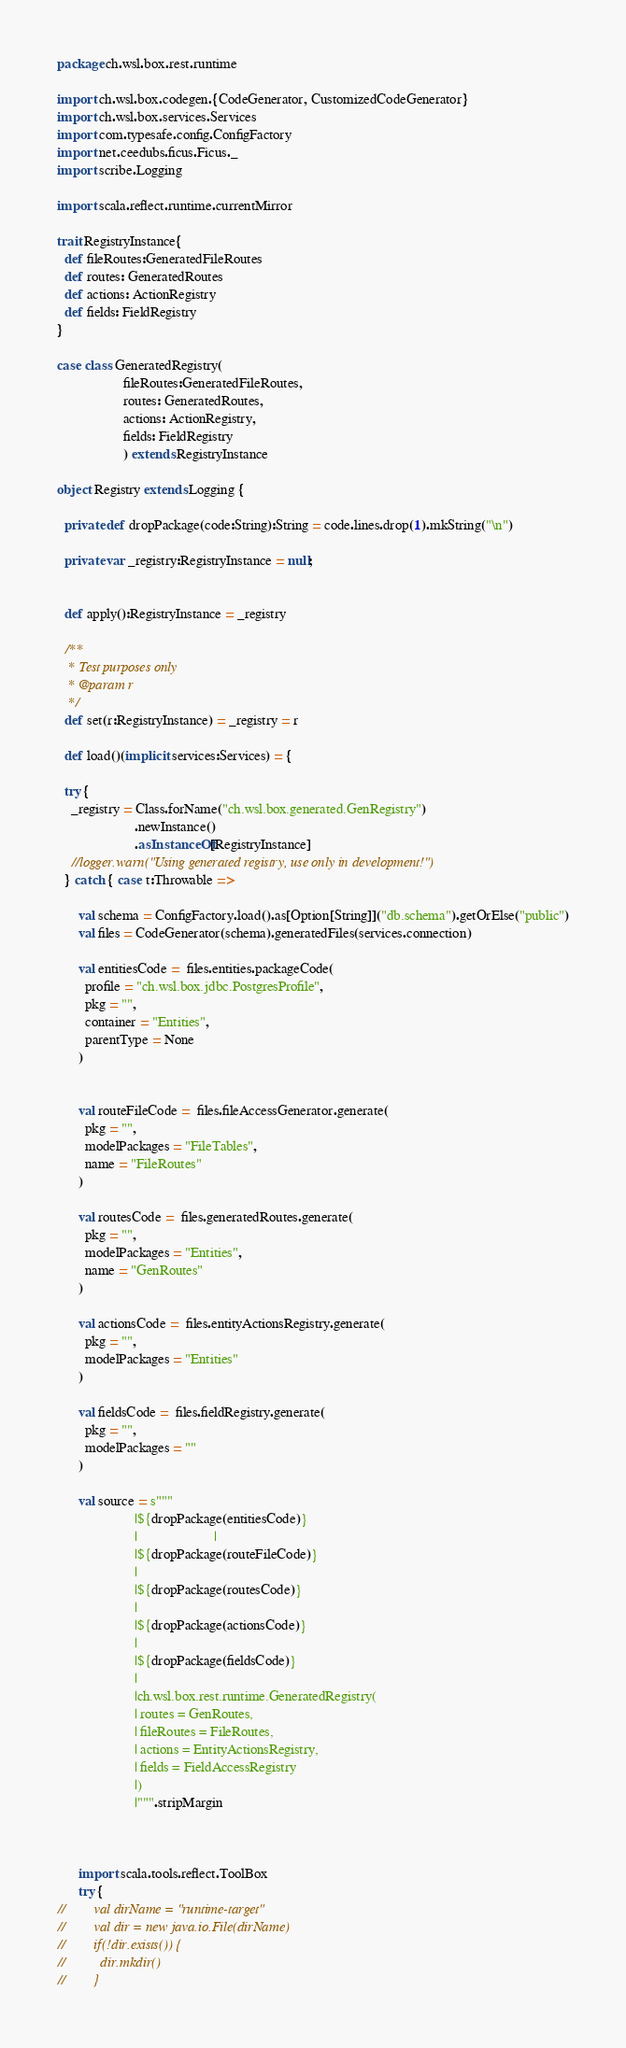<code> <loc_0><loc_0><loc_500><loc_500><_Scala_>package ch.wsl.box.rest.runtime

import ch.wsl.box.codegen.{CodeGenerator, CustomizedCodeGenerator}
import ch.wsl.box.services.Services
import com.typesafe.config.ConfigFactory
import net.ceedubs.ficus.Ficus._
import scribe.Logging

import scala.reflect.runtime.currentMirror

trait RegistryInstance{
  def fileRoutes:GeneratedFileRoutes
  def routes: GeneratedRoutes
  def actions: ActionRegistry
  def fields: FieldRegistry
}

case class GeneratedRegistry(
                   fileRoutes:GeneratedFileRoutes,
                   routes: GeneratedRoutes,
                   actions: ActionRegistry,
                   fields: FieldRegistry
                   ) extends RegistryInstance

object Registry extends Logging {

  private def dropPackage(code:String):String = code.lines.drop(1).mkString("\n")

  private var _registry:RegistryInstance = null;


  def apply():RegistryInstance = _registry

  /**
   * Test purposes only
   * @param r
   */
  def set(r:RegistryInstance) = _registry = r

  def load()(implicit services:Services) = {

  try {
    _registry = Class.forName("ch.wsl.box.generated.GenRegistry")
                      .newInstance()
                      .asInstanceOf[RegistryInstance]
    //logger.warn("Using generated registry, use only in development!")
  } catch { case t:Throwable =>

      val schema = ConfigFactory.load().as[Option[String]]("db.schema").getOrElse("public")
      val files = CodeGenerator(schema).generatedFiles(services.connection)

      val entitiesCode =  files.entities.packageCode(
        profile = "ch.wsl.box.jdbc.PostgresProfile",
        pkg = "",
        container = "Entities",
        parentType = None
      )


      val routeFileCode =  files.fileAccessGenerator.generate(
        pkg = "",
        modelPackages = "FileTables",
        name = "FileRoutes"
      )

      val routesCode =  files.generatedRoutes.generate(
        pkg = "",
        modelPackages = "Entities",
        name = "GenRoutes"
      )

      val actionsCode =  files.entityActionsRegistry.generate(
        pkg = "",
        modelPackages = "Entities"
      )

      val fieldsCode =  files.fieldRegistry.generate(
        pkg = "",
        modelPackages = ""
      )

      val source = s"""
                      |${dropPackage(entitiesCode)}
                      |                      |
                      |${dropPackage(routeFileCode)}
                      |
                      |${dropPackage(routesCode)}
                      |
                      |${dropPackage(actionsCode)}
                      |
                      |${dropPackage(fieldsCode)}
                      |
                      |ch.wsl.box.rest.runtime.GeneratedRegistry(
                      | routes = GenRoutes,
                      | fileRoutes = FileRoutes,
                      | actions = EntityActionsRegistry,
                      | fields = FieldAccessRegistry
                      |)
                      |""".stripMargin



      import scala.tools.reflect.ToolBox
      try {
//        val dirName = "runtime-target"
//        val dir = new java.io.File(dirName)
//        if(!dir.exists()) {
//          dir.mkdir()
//        }</code> 